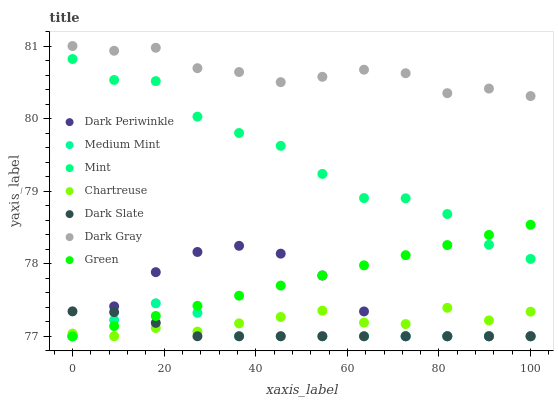Does Dark Slate have the minimum area under the curve?
Answer yes or no. Yes. Does Dark Gray have the maximum area under the curve?
Answer yes or no. Yes. Does Dark Gray have the minimum area under the curve?
Answer yes or no. No. Does Dark Slate have the maximum area under the curve?
Answer yes or no. No. Is Green the smoothest?
Answer yes or no. Yes. Is Mint the roughest?
Answer yes or no. Yes. Is Dark Gray the smoothest?
Answer yes or no. No. Is Dark Gray the roughest?
Answer yes or no. No. Does Medium Mint have the lowest value?
Answer yes or no. Yes. Does Dark Gray have the lowest value?
Answer yes or no. No. Does Dark Gray have the highest value?
Answer yes or no. Yes. Does Dark Slate have the highest value?
Answer yes or no. No. Is Chartreuse less than Dark Gray?
Answer yes or no. Yes. Is Dark Gray greater than Medium Mint?
Answer yes or no. Yes. Does Dark Slate intersect Chartreuse?
Answer yes or no. Yes. Is Dark Slate less than Chartreuse?
Answer yes or no. No. Is Dark Slate greater than Chartreuse?
Answer yes or no. No. Does Chartreuse intersect Dark Gray?
Answer yes or no. No. 